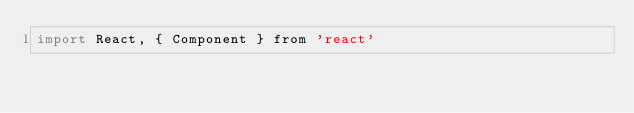Convert code to text. <code><loc_0><loc_0><loc_500><loc_500><_JavaScript_>import React, { Component } from 'react'</code> 